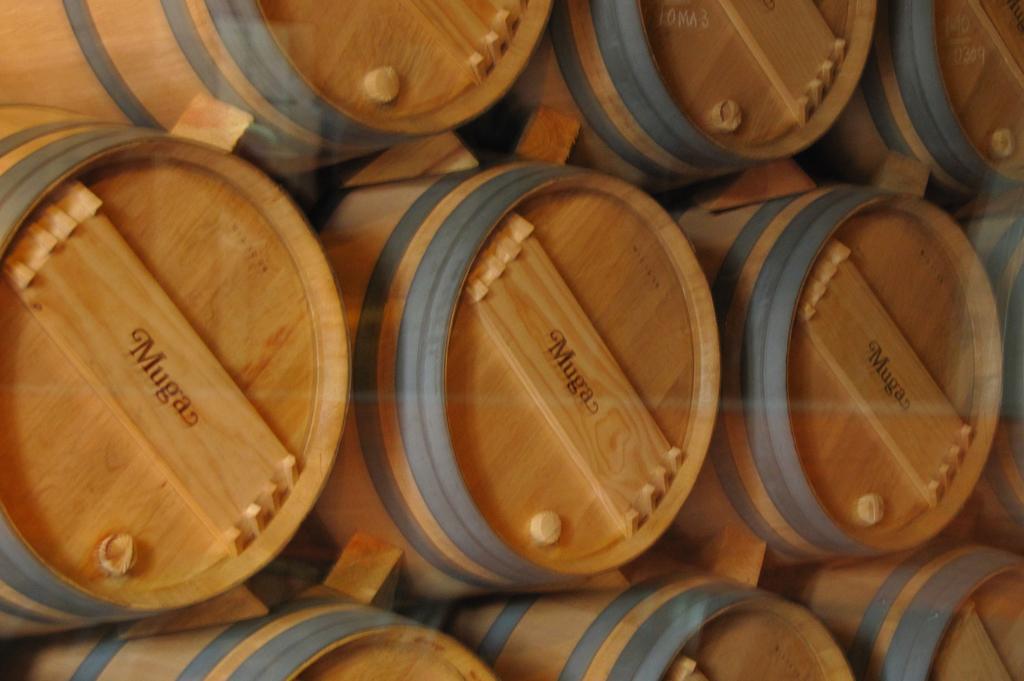Please provide a concise description of this image. In this picture we can see barrels and names on wooden planks. 